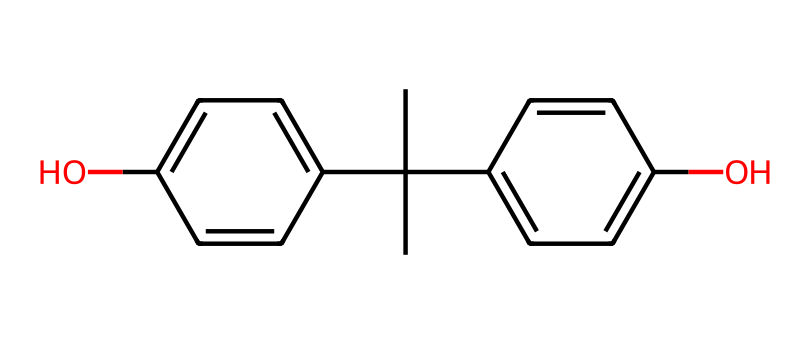What is the molecular formula of bisphenol A? To determine the molecular formula, we can analyze the number of each type of atom present in the chemical structure. In this case, there are 15 carbon atoms (C), 16 hydrogen atoms (H), and 2 oxygen atoms (O) in the structure. Thus, the molecular formula is C15H16O2.
Answer: C15H16O2 How many hydroxyl (–OH) groups are present in bisphenol A? By examining the structure, we can identify that there are two functional groups which are hydroxyl groups (–OH) attached to the aromatic rings. Hence, the count of hydroxyl groups is two.
Answer: 2 What type of compound is bisphenol A? Bisphenol A contains at least one hydroxyl group and is derived from an aromatic parent structure, making it a phenolic compound categorized under phenols.
Answer: phenolic Identify the number of rings in bisphenol A. In order to determine the number of rings, we can visualize the structure which is made up of two benzene rings. Therefore, the total number of rings present in the compound is two.
Answer: 2 What is the significance of the hydroxyl groups in bisphenol A? The hydroxyl groups in bisphenol A impart important chemical properties, such as increased polarity and the ability to form hydrogen bonds, which enhance its reactivity and functional capabilities in various applications like plastics.
Answer: reactivity 